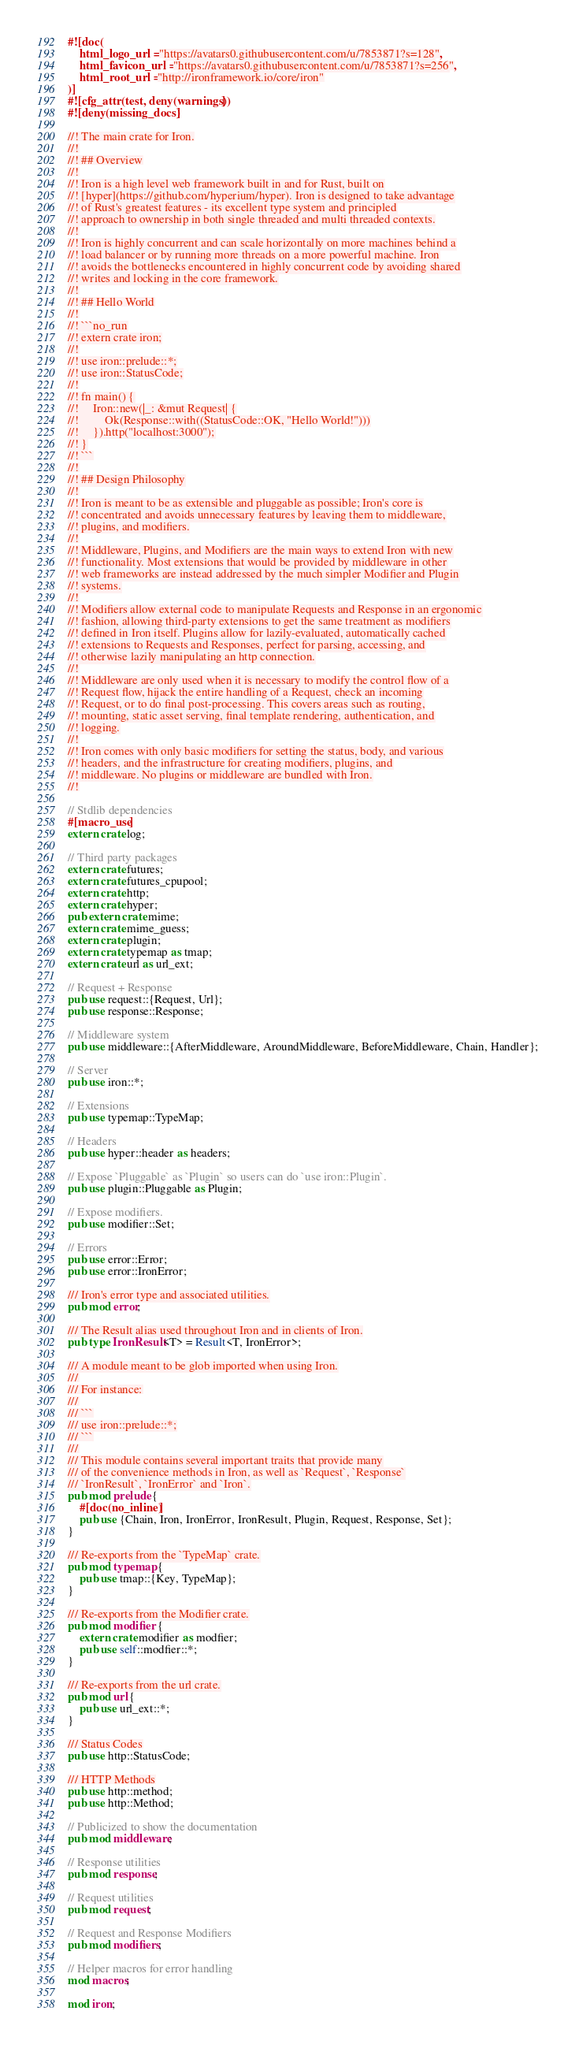Convert code to text. <code><loc_0><loc_0><loc_500><loc_500><_Rust_>#![doc(
    html_logo_url = "https://avatars0.githubusercontent.com/u/7853871?s=128",
    html_favicon_url = "https://avatars0.githubusercontent.com/u/7853871?s=256",
    html_root_url = "http://ironframework.io/core/iron"
)]
#![cfg_attr(test, deny(warnings))]
#![deny(missing_docs)]

//! The main crate for Iron.
//!
//! ## Overview
//!
//! Iron is a high level web framework built in and for Rust, built on
//! [hyper](https://github.com/hyperium/hyper). Iron is designed to take advantage
//! of Rust's greatest features - its excellent type system and principled
//! approach to ownership in both single threaded and multi threaded contexts.
//!
//! Iron is highly concurrent and can scale horizontally on more machines behind a
//! load balancer or by running more threads on a more powerful machine. Iron
//! avoids the bottlenecks encountered in highly concurrent code by avoiding shared
//! writes and locking in the core framework.
//!
//! ## Hello World
//!
//! ```no_run
//! extern crate iron;
//!
//! use iron::prelude::*;
//! use iron::StatusCode;
//!
//! fn main() {
//!     Iron::new(|_: &mut Request| {
//!         Ok(Response::with((StatusCode::OK, "Hello World!")))
//!     }).http("localhost:3000");
//! }
//! ```
//!
//! ## Design Philosophy
//!
//! Iron is meant to be as extensible and pluggable as possible; Iron's core is
//! concentrated and avoids unnecessary features by leaving them to middleware,
//! plugins, and modifiers.
//!
//! Middleware, Plugins, and Modifiers are the main ways to extend Iron with new
//! functionality. Most extensions that would be provided by middleware in other
//! web frameworks are instead addressed by the much simpler Modifier and Plugin
//! systems.
//!
//! Modifiers allow external code to manipulate Requests and Response in an ergonomic
//! fashion, allowing third-party extensions to get the same treatment as modifiers
//! defined in Iron itself. Plugins allow for lazily-evaluated, automatically cached
//! extensions to Requests and Responses, perfect for parsing, accessing, and
//! otherwise lazily manipulating an http connection.
//!
//! Middleware are only used when it is necessary to modify the control flow of a
//! Request flow, hijack the entire handling of a Request, check an incoming
//! Request, or to do final post-processing. This covers areas such as routing,
//! mounting, static asset serving, final template rendering, authentication, and
//! logging.
//!
//! Iron comes with only basic modifiers for setting the status, body, and various
//! headers, and the infrastructure for creating modifiers, plugins, and
//! middleware. No plugins or middleware are bundled with Iron.
//!

// Stdlib dependencies
#[macro_use]
extern crate log;

// Third party packages
extern crate futures;
extern crate futures_cpupool;
extern crate http;
extern crate hyper;
pub extern crate mime;
extern crate mime_guess;
extern crate plugin;
extern crate typemap as tmap;
extern crate url as url_ext;

// Request + Response
pub use request::{Request, Url};
pub use response::Response;

// Middleware system
pub use middleware::{AfterMiddleware, AroundMiddleware, BeforeMiddleware, Chain, Handler};

// Server
pub use iron::*;

// Extensions
pub use typemap::TypeMap;

// Headers
pub use hyper::header as headers;

// Expose `Pluggable` as `Plugin` so users can do `use iron::Plugin`.
pub use plugin::Pluggable as Plugin;

// Expose modifiers.
pub use modifier::Set;

// Errors
pub use error::Error;
pub use error::IronError;

/// Iron's error type and associated utilities.
pub mod error;

/// The Result alias used throughout Iron and in clients of Iron.
pub type IronResult<T> = Result<T, IronError>;

/// A module meant to be glob imported when using Iron.
///
/// For instance:
///
/// ```
/// use iron::prelude::*;
/// ```
///
/// This module contains several important traits that provide many
/// of the convenience methods in Iron, as well as `Request`, `Response`
/// `IronResult`, `IronError` and `Iron`.
pub mod prelude {
    #[doc(no_inline)]
    pub use {Chain, Iron, IronError, IronResult, Plugin, Request, Response, Set};
}

/// Re-exports from the `TypeMap` crate.
pub mod typemap {
    pub use tmap::{Key, TypeMap};
}

/// Re-exports from the Modifier crate.
pub mod modifier {
    extern crate modifier as modfier;
    pub use self::modfier::*;
}

/// Re-exports from the url crate.
pub mod url {
    pub use url_ext::*;
}

/// Status Codes
pub use http::StatusCode;

/// HTTP Methods
pub use http::method;
pub use http::Method;

// Publicized to show the documentation
pub mod middleware;

// Response utilities
pub mod response;

// Request utilities
pub mod request;

// Request and Response Modifiers
pub mod modifiers;

// Helper macros for error handling
mod macros;

mod iron;
</code> 